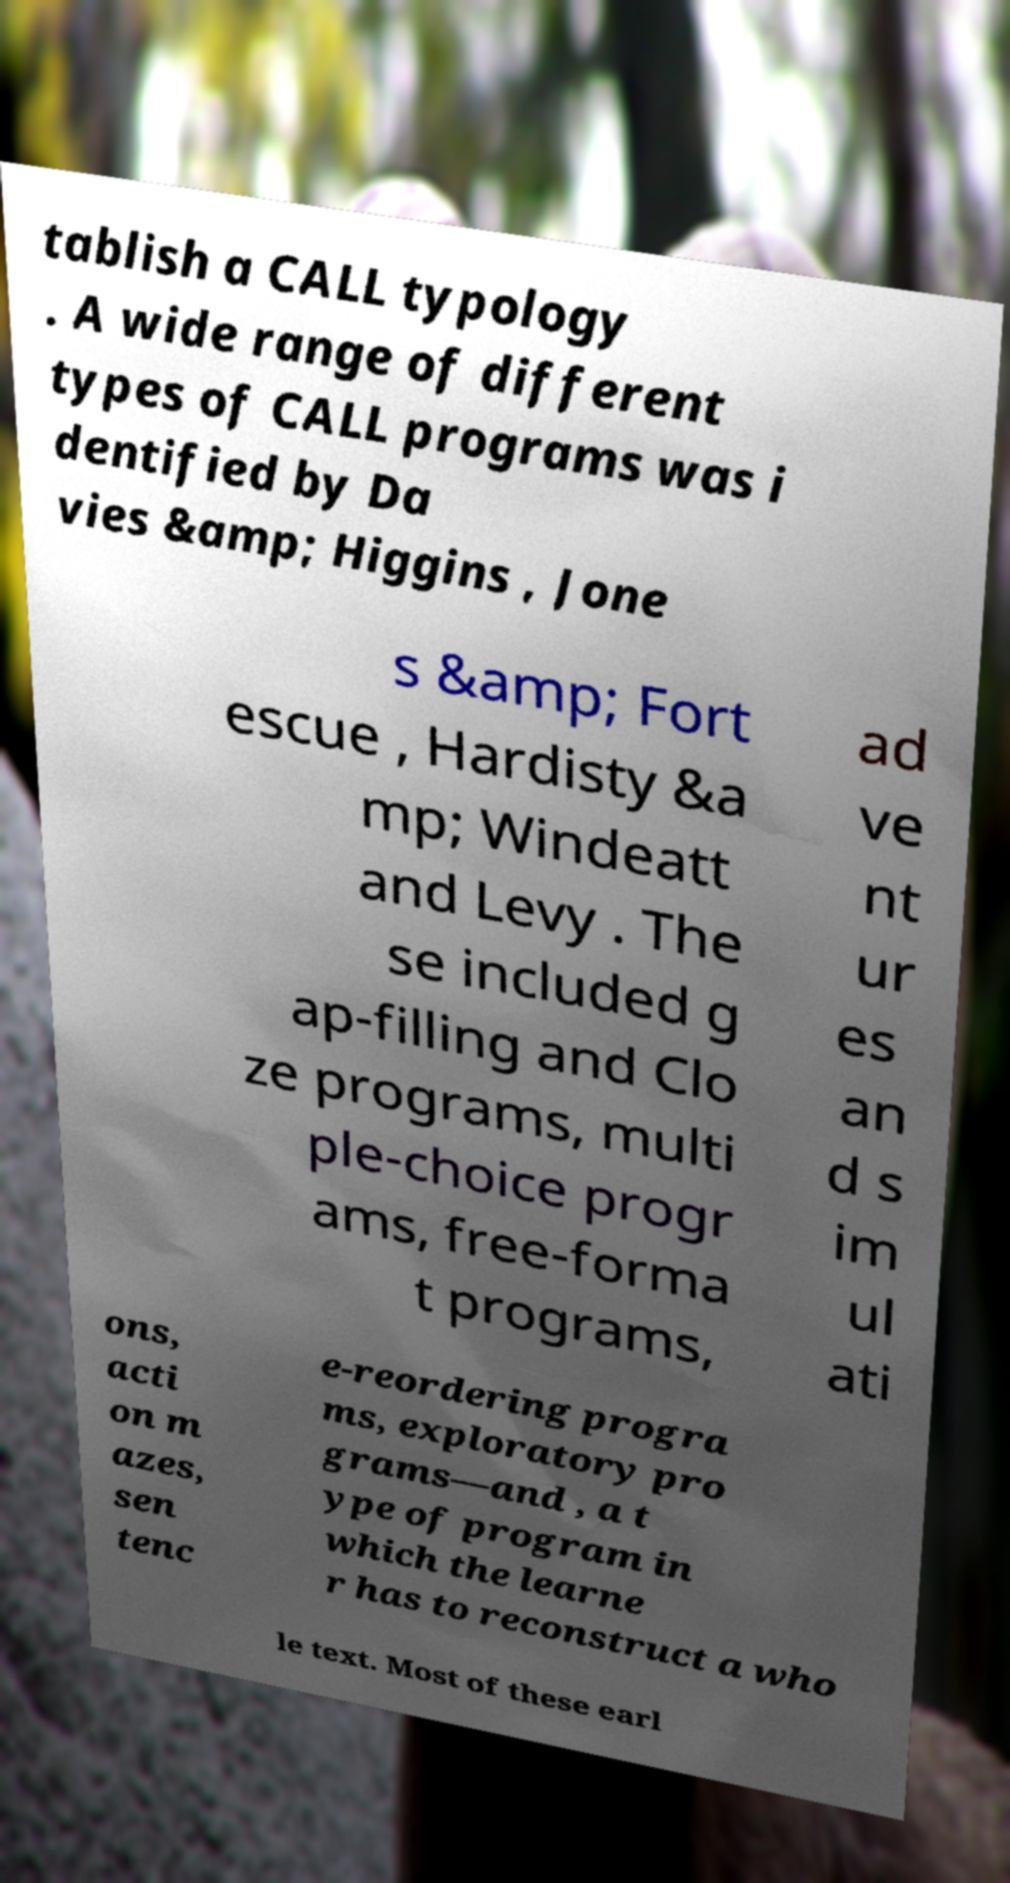For documentation purposes, I need the text within this image transcribed. Could you provide that? tablish a CALL typology . A wide range of different types of CALL programs was i dentified by Da vies &amp; Higgins , Jone s &amp; Fort escue , Hardisty &a mp; Windeatt and Levy . The se included g ap-filling and Clo ze programs, multi ple-choice progr ams, free-forma t programs, ad ve nt ur es an d s im ul ati ons, acti on m azes, sen tenc e-reordering progra ms, exploratory pro grams—and , a t ype of program in which the learne r has to reconstruct a who le text. Most of these earl 